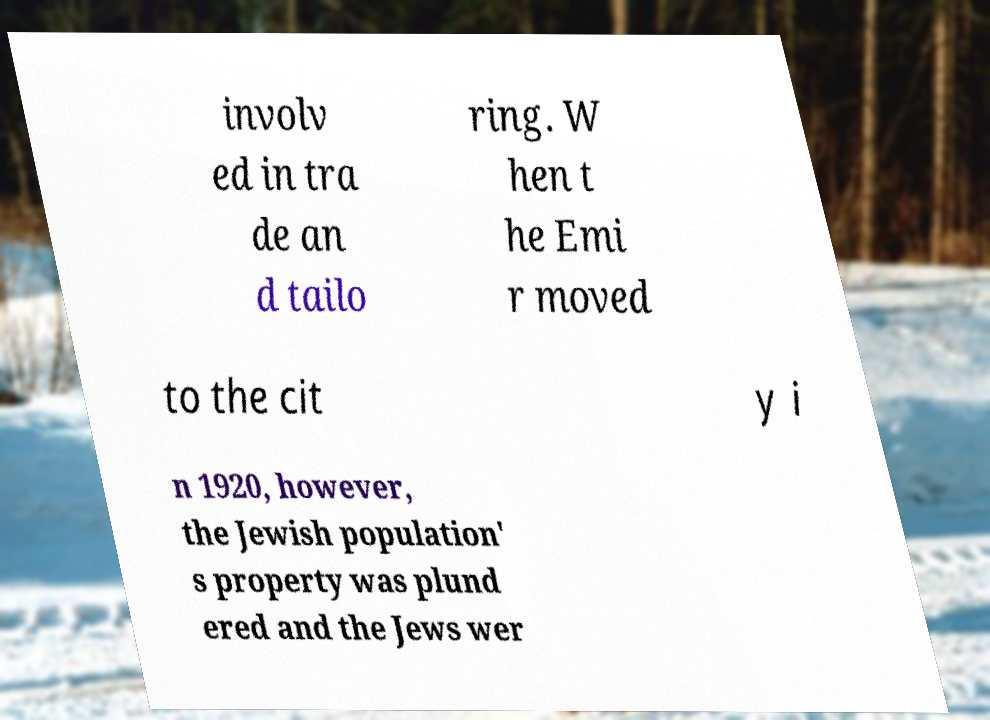Could you extract and type out the text from this image? involv ed in tra de an d tailo ring. W hen t he Emi r moved to the cit y i n 1920, however, the Jewish population' s property was plund ered and the Jews wer 